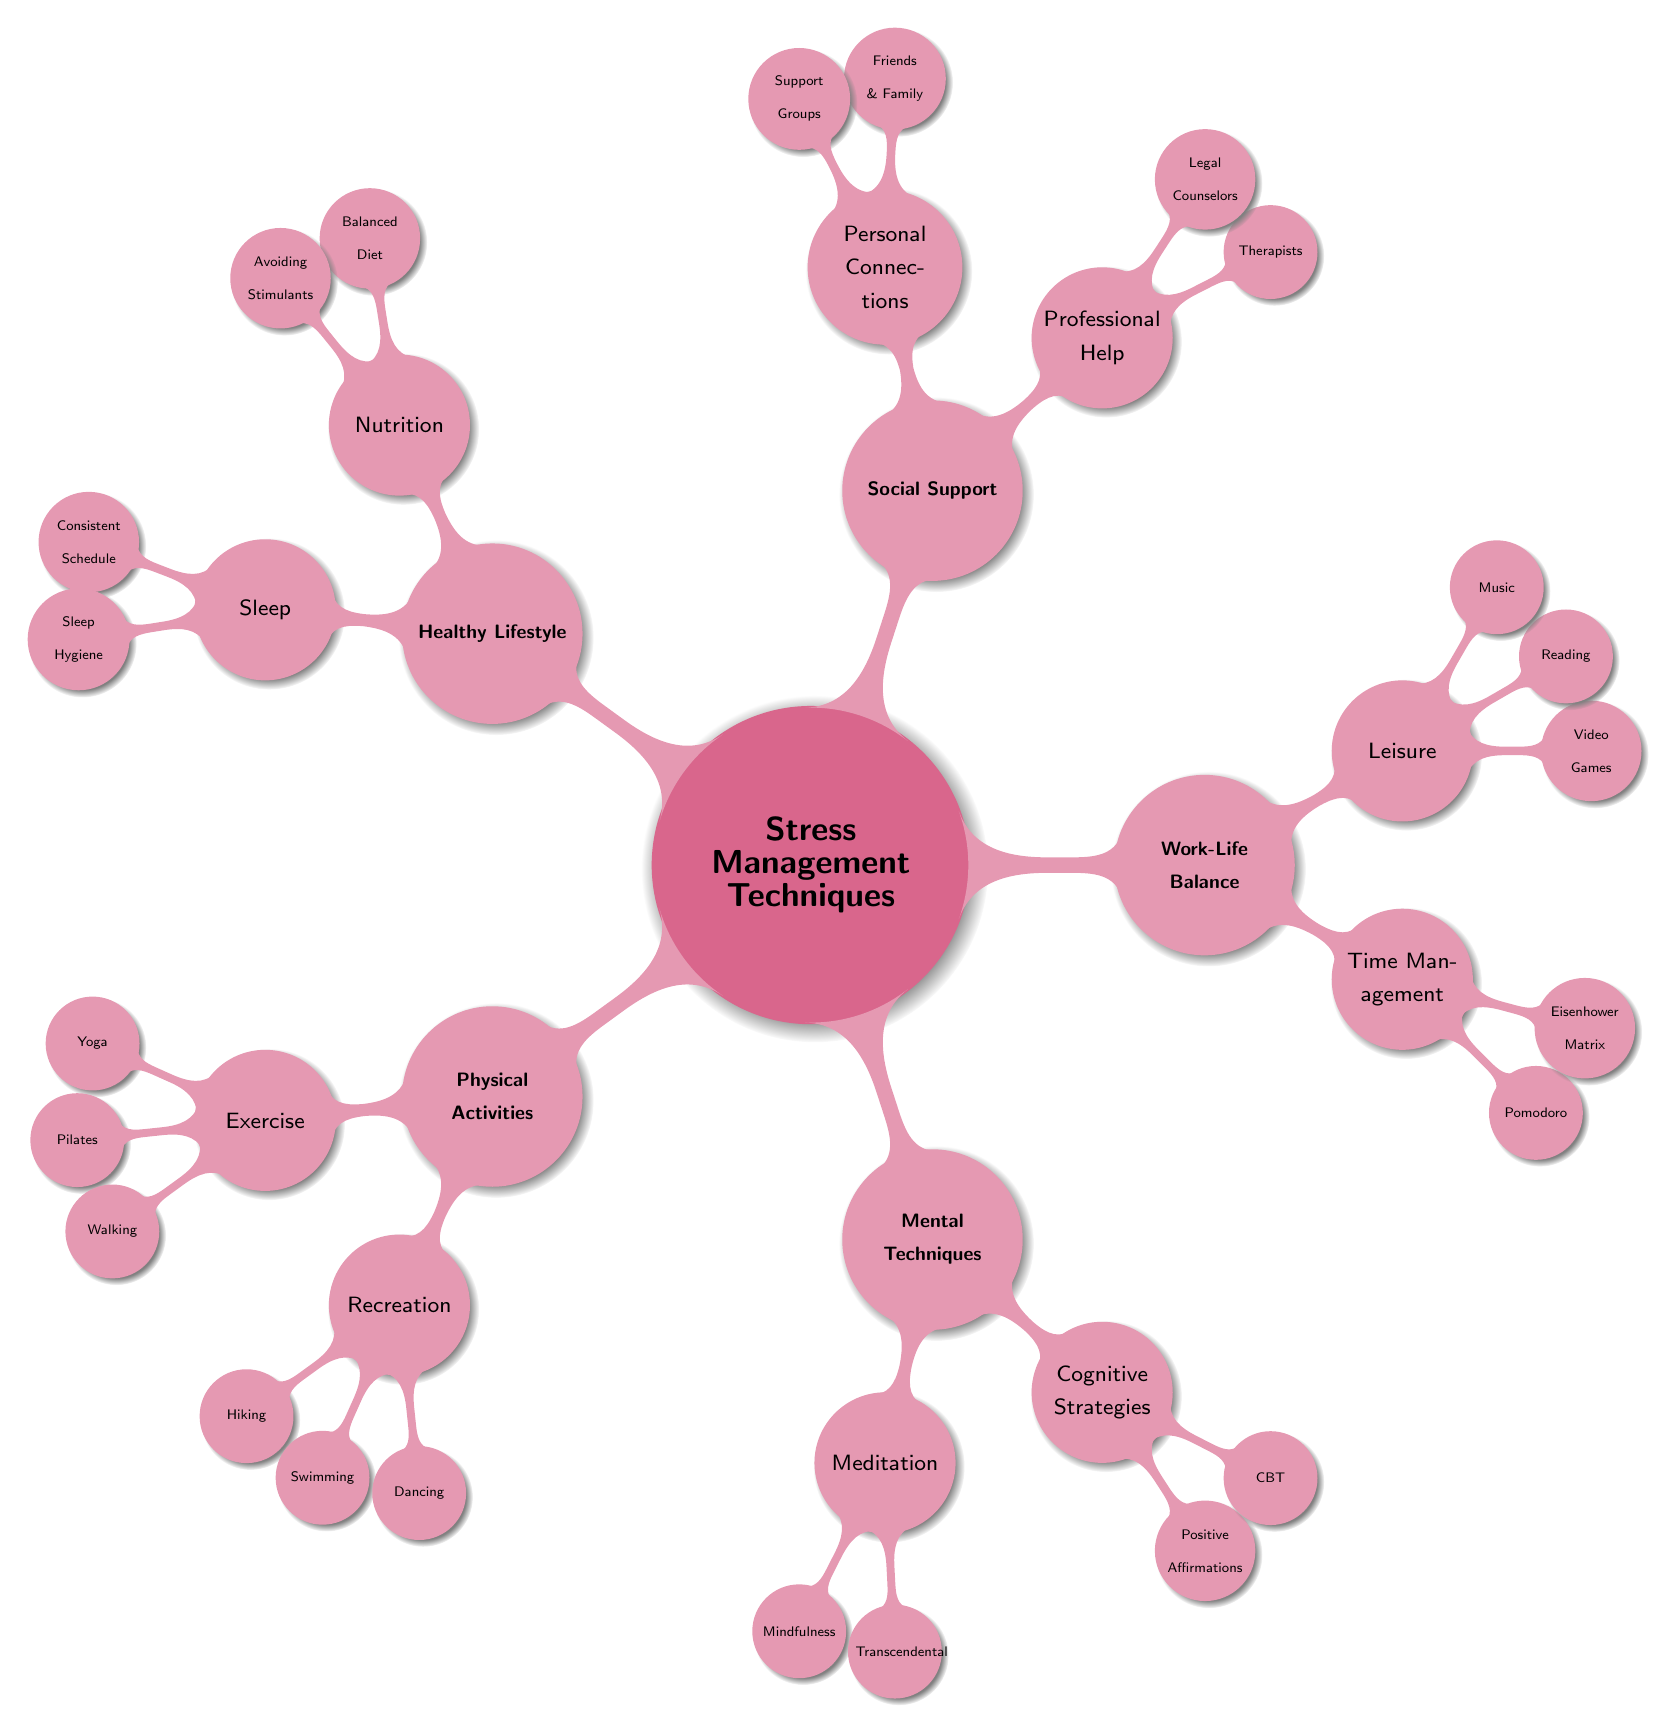What are the two main categories under Physical Activities? The diagram shows Physical Activities as a main topic with two subcategories: Exercise and Recreation.
Answer: Exercise, Recreation How many techniques are listed under Mental Techniques? Under Mental Techniques, there are two subcategories: Meditation and Cognitive Strategies. Each of these has two techniques listed. Thus, there are a total of four techniques.
Answer: Four Which technique is listed under Work-Life Balance that is specifically about managing time? Work-Life Balance includes Time Management as a subcategory. The diagram lists the Pomodoro Technique and the Eisenhower Matrix under this.
Answer: Time Management What is one Healthy Lifestyle practice related to sleep? The Healthy Lifestyle category includes a subcategory for Sleep, which has Consistent Sleep Schedule and Sleep Hygiene as its techniques. Either can be accepted.
Answer: Sleep Name a form of Social Support that involves obtaining professional advice. The diagram indicates Professional Help as a subcategory under Social Support, listing Therapists and Legal Counselors as examples of professionals.
Answer: Professional Help Which Physical Activities technique is specifically related to the water? Among the options listed under Recreation in Physical Activities, Swimming is specifically related to water-based activity.
Answer: Swimming How does the number of techniques in Mental Techniques compare to those in Healthy Lifestyle? Mental Techniques has four techniques, while Healthy Lifestyle also has four discussed techniques (Nutrition and Sleep each with two). They are equal in number.
Answer: Equal Identify one cognitive strategy used for stress management. The diagram lists Cognitive Strategies as a subcategory under Mental Techniques, which includes Positive Affirmations and Cognitive Behavioral Therapy. Each is a valid answer.
Answer: Cognitive Strategies What is the primary focus of the diagram overall? The main topic of the mind map is Stress Management Techniques, encompassing various strategies for managing stress in different categories.
Answer: Stress Management Techniques 